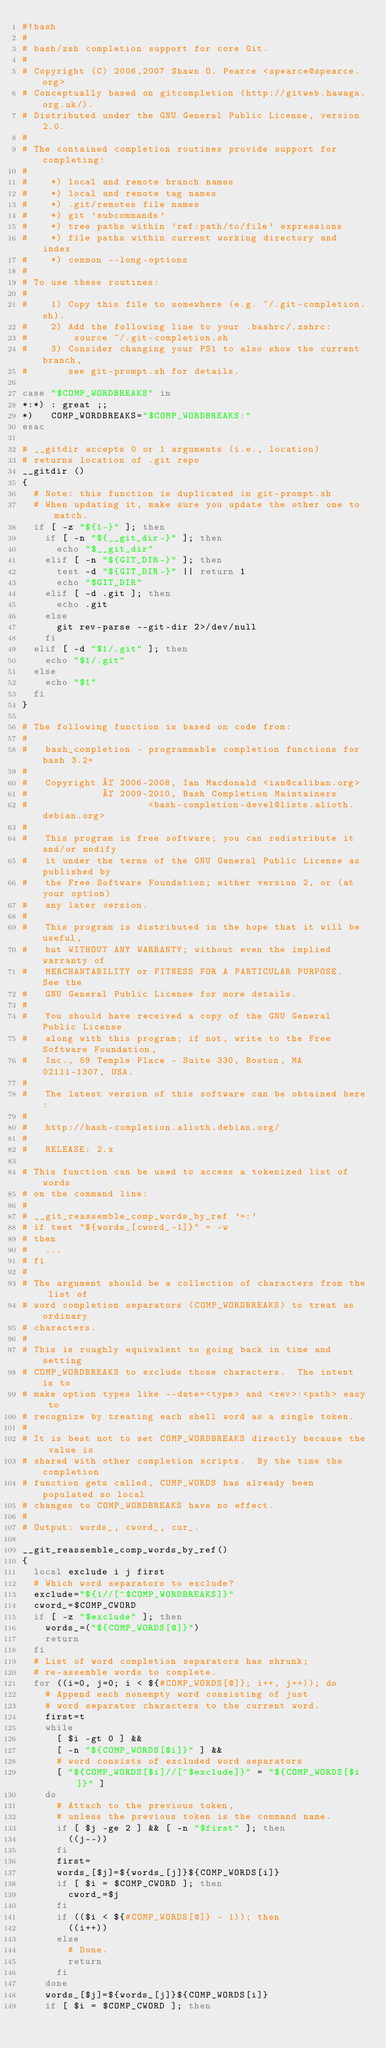Convert code to text. <code><loc_0><loc_0><loc_500><loc_500><_Bash_>#!bash
#
# bash/zsh completion support for core Git.
#
# Copyright (C) 2006,2007 Shawn O. Pearce <spearce@spearce.org>
# Conceptually based on gitcompletion (http://gitweb.hawaga.org.uk/).
# Distributed under the GNU General Public License, version 2.0.
#
# The contained completion routines provide support for completing:
#
#    *) local and remote branch names
#    *) local and remote tag names
#    *) .git/remotes file names
#    *) git 'subcommands'
#    *) tree paths within 'ref:path/to/file' expressions
#    *) file paths within current working directory and index
#    *) common --long-options
#
# To use these routines:
#
#    1) Copy this file to somewhere (e.g. ~/.git-completion.sh).
#    2) Add the following line to your .bashrc/.zshrc:
#        source ~/.git-completion.sh
#    3) Consider changing your PS1 to also show the current branch,
#       see git-prompt.sh for details.

case "$COMP_WORDBREAKS" in
*:*) : great ;;
*)   COMP_WORDBREAKS="$COMP_WORDBREAKS:"
esac

# __gitdir accepts 0 or 1 arguments (i.e., location)
# returns location of .git repo
__gitdir ()
{
	# Note: this function is duplicated in git-prompt.sh
	# When updating it, make sure you update the other one to match.
	if [ -z "${1-}" ]; then
		if [ -n "${__git_dir-}" ]; then
			echo "$__git_dir"
		elif [ -n "${GIT_DIR-}" ]; then
			test -d "${GIT_DIR-}" || return 1
			echo "$GIT_DIR"
		elif [ -d .git ]; then
			echo .git
		else
			git rev-parse --git-dir 2>/dev/null
		fi
	elif [ -d "$1/.git" ]; then
		echo "$1/.git"
	else
		echo "$1"
	fi
}

# The following function is based on code from:
#
#   bash_completion - programmable completion functions for bash 3.2+
#
#   Copyright © 2006-2008, Ian Macdonald <ian@caliban.org>
#             © 2009-2010, Bash Completion Maintainers
#                     <bash-completion-devel@lists.alioth.debian.org>
#
#   This program is free software; you can redistribute it and/or modify
#   it under the terms of the GNU General Public License as published by
#   the Free Software Foundation; either version 2, or (at your option)
#   any later version.
#
#   This program is distributed in the hope that it will be useful,
#   but WITHOUT ANY WARRANTY; without even the implied warranty of
#   MERCHANTABILITY or FITNESS FOR A PARTICULAR PURPOSE.  See the
#   GNU General Public License for more details.
#
#   You should have received a copy of the GNU General Public License
#   along with this program; if not, write to the Free Software Foundation,
#   Inc., 59 Temple Place - Suite 330, Boston, MA 02111-1307, USA.
#
#   The latest version of this software can be obtained here:
#
#   http://bash-completion.alioth.debian.org/
#
#   RELEASE: 2.x

# This function can be used to access a tokenized list of words
# on the command line:
#
#	__git_reassemble_comp_words_by_ref '=:'
#	if test "${words_[cword_-1]}" = -w
#	then
#		...
#	fi
#
# The argument should be a collection of characters from the list of
# word completion separators (COMP_WORDBREAKS) to treat as ordinary
# characters.
#
# This is roughly equivalent to going back in time and setting
# COMP_WORDBREAKS to exclude those characters.  The intent is to
# make option types like --date=<type> and <rev>:<path> easy to
# recognize by treating each shell word as a single token.
#
# It is best not to set COMP_WORDBREAKS directly because the value is
# shared with other completion scripts.  By the time the completion
# function gets called, COMP_WORDS has already been populated so local
# changes to COMP_WORDBREAKS have no effect.
#
# Output: words_, cword_, cur_.

__git_reassemble_comp_words_by_ref()
{
	local exclude i j first
	# Which word separators to exclude?
	exclude="${1//[^$COMP_WORDBREAKS]}"
	cword_=$COMP_CWORD
	if [ -z "$exclude" ]; then
		words_=("${COMP_WORDS[@]}")
		return
	fi
	# List of word completion separators has shrunk;
	# re-assemble words to complete.
	for ((i=0, j=0; i < ${#COMP_WORDS[@]}; i++, j++)); do
		# Append each nonempty word consisting of just
		# word separator characters to the current word.
		first=t
		while
			[ $i -gt 0 ] &&
			[ -n "${COMP_WORDS[$i]}" ] &&
			# word consists of excluded word separators
			[ "${COMP_WORDS[$i]//[^$exclude]}" = "${COMP_WORDS[$i]}" ]
		do
			# Attach to the previous token,
			# unless the previous token is the command name.
			if [ $j -ge 2 ] && [ -n "$first" ]; then
				((j--))
			fi
			first=
			words_[$j]=${words_[j]}${COMP_WORDS[i]}
			if [ $i = $COMP_CWORD ]; then
				cword_=$j
			fi
			if (($i < ${#COMP_WORDS[@]} - 1)); then
				((i++))
			else
				# Done.
				return
			fi
		done
		words_[$j]=${words_[j]}${COMP_WORDS[i]}
		if [ $i = $COMP_CWORD ]; then</code> 